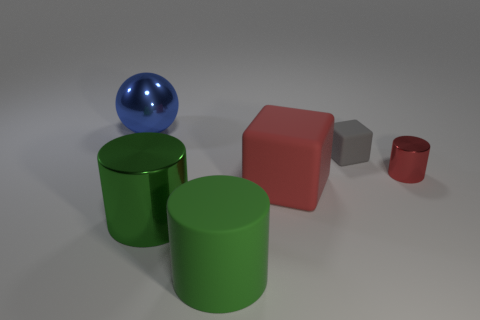Add 1 big blue metal blocks. How many objects exist? 7 Subtract all green matte cylinders. How many cylinders are left? 2 Subtract all green cylinders. How many cylinders are left? 1 Subtract all spheres. How many objects are left? 5 Subtract all green objects. Subtract all small things. How many objects are left? 2 Add 5 large blue shiny objects. How many large blue shiny objects are left? 6 Add 2 green rubber things. How many green rubber things exist? 3 Subtract 0 gray balls. How many objects are left? 6 Subtract all cyan cylinders. Subtract all purple blocks. How many cylinders are left? 3 Subtract all purple spheres. How many gray blocks are left? 1 